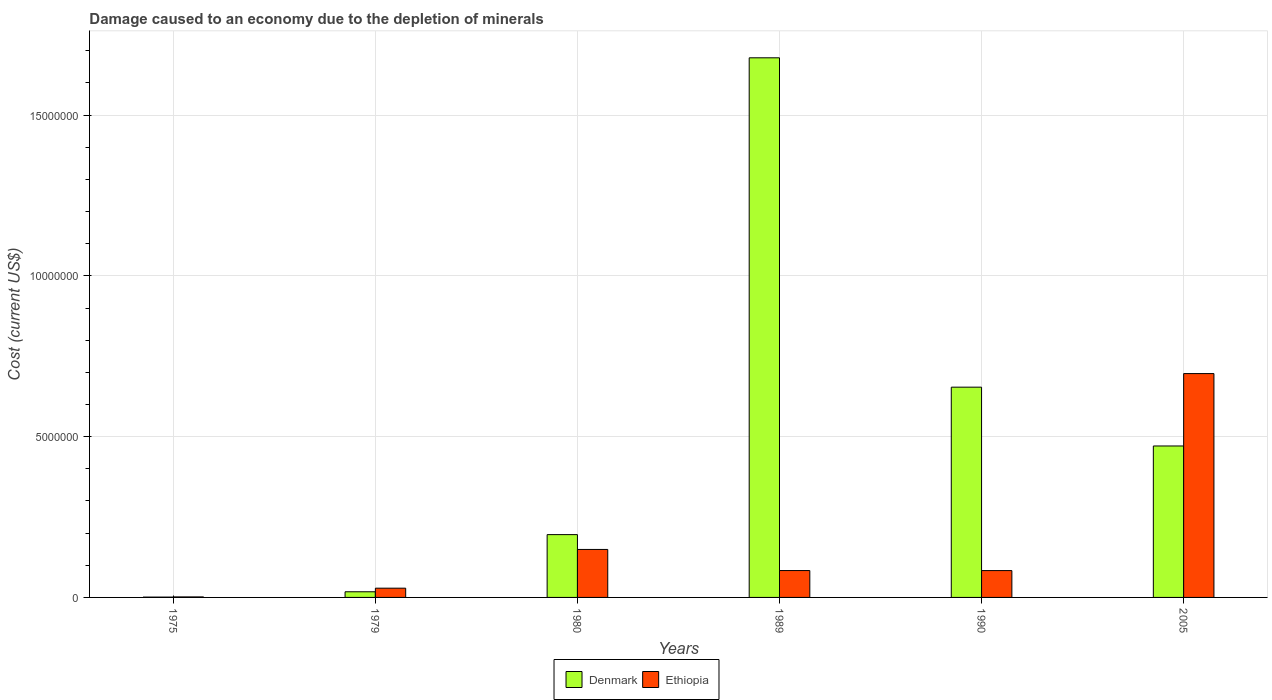How many different coloured bars are there?
Make the answer very short. 2. How many groups of bars are there?
Your answer should be very brief. 6. Are the number of bars on each tick of the X-axis equal?
Provide a short and direct response. Yes. What is the label of the 3rd group of bars from the left?
Your answer should be very brief. 1980. What is the cost of damage caused due to the depletion of minerals in Ethiopia in 1990?
Offer a terse response. 8.35e+05. Across all years, what is the maximum cost of damage caused due to the depletion of minerals in Denmark?
Offer a very short reply. 1.68e+07. Across all years, what is the minimum cost of damage caused due to the depletion of minerals in Ethiopia?
Offer a terse response. 1.59e+04. In which year was the cost of damage caused due to the depletion of minerals in Ethiopia minimum?
Provide a succinct answer. 1975. What is the total cost of damage caused due to the depletion of minerals in Ethiopia in the graph?
Offer a very short reply. 1.04e+07. What is the difference between the cost of damage caused due to the depletion of minerals in Ethiopia in 1975 and that in 2005?
Offer a terse response. -6.95e+06. What is the difference between the cost of damage caused due to the depletion of minerals in Ethiopia in 1979 and the cost of damage caused due to the depletion of minerals in Denmark in 1990?
Offer a terse response. -6.25e+06. What is the average cost of damage caused due to the depletion of minerals in Ethiopia per year?
Offer a terse response. 1.74e+06. In the year 1989, what is the difference between the cost of damage caused due to the depletion of minerals in Denmark and cost of damage caused due to the depletion of minerals in Ethiopia?
Provide a short and direct response. 1.59e+07. In how many years, is the cost of damage caused due to the depletion of minerals in Denmark greater than 4000000 US$?
Provide a succinct answer. 3. What is the ratio of the cost of damage caused due to the depletion of minerals in Denmark in 1975 to that in 2005?
Provide a succinct answer. 0. Is the cost of damage caused due to the depletion of minerals in Denmark in 1980 less than that in 2005?
Make the answer very short. Yes. What is the difference between the highest and the second highest cost of damage caused due to the depletion of minerals in Ethiopia?
Offer a very short reply. 5.47e+06. What is the difference between the highest and the lowest cost of damage caused due to the depletion of minerals in Ethiopia?
Provide a succinct answer. 6.95e+06. In how many years, is the cost of damage caused due to the depletion of minerals in Ethiopia greater than the average cost of damage caused due to the depletion of minerals in Ethiopia taken over all years?
Make the answer very short. 1. Is the sum of the cost of damage caused due to the depletion of minerals in Ethiopia in 1980 and 1990 greater than the maximum cost of damage caused due to the depletion of minerals in Denmark across all years?
Your response must be concise. No. What does the 1st bar from the right in 2005 represents?
Provide a short and direct response. Ethiopia. Are all the bars in the graph horizontal?
Ensure brevity in your answer.  No. What is the difference between two consecutive major ticks on the Y-axis?
Provide a succinct answer. 5.00e+06. Are the values on the major ticks of Y-axis written in scientific E-notation?
Ensure brevity in your answer.  No. Where does the legend appear in the graph?
Your answer should be compact. Bottom center. How are the legend labels stacked?
Your answer should be very brief. Horizontal. What is the title of the graph?
Provide a short and direct response. Damage caused to an economy due to the depletion of minerals. Does "Slovenia" appear as one of the legend labels in the graph?
Provide a succinct answer. No. What is the label or title of the Y-axis?
Your answer should be compact. Cost (current US$). What is the Cost (current US$) in Denmark in 1975?
Keep it short and to the point. 1.03e+04. What is the Cost (current US$) in Ethiopia in 1975?
Ensure brevity in your answer.  1.59e+04. What is the Cost (current US$) of Denmark in 1979?
Provide a short and direct response. 1.76e+05. What is the Cost (current US$) of Ethiopia in 1979?
Offer a very short reply. 2.88e+05. What is the Cost (current US$) of Denmark in 1980?
Provide a short and direct response. 1.95e+06. What is the Cost (current US$) in Ethiopia in 1980?
Give a very brief answer. 1.49e+06. What is the Cost (current US$) in Denmark in 1989?
Offer a very short reply. 1.68e+07. What is the Cost (current US$) of Ethiopia in 1989?
Provide a succinct answer. 8.36e+05. What is the Cost (current US$) in Denmark in 1990?
Your answer should be compact. 6.54e+06. What is the Cost (current US$) in Ethiopia in 1990?
Provide a succinct answer. 8.35e+05. What is the Cost (current US$) of Denmark in 2005?
Give a very brief answer. 4.71e+06. What is the Cost (current US$) in Ethiopia in 2005?
Your answer should be very brief. 6.96e+06. Across all years, what is the maximum Cost (current US$) of Denmark?
Offer a terse response. 1.68e+07. Across all years, what is the maximum Cost (current US$) of Ethiopia?
Provide a succinct answer. 6.96e+06. Across all years, what is the minimum Cost (current US$) of Denmark?
Give a very brief answer. 1.03e+04. Across all years, what is the minimum Cost (current US$) of Ethiopia?
Give a very brief answer. 1.59e+04. What is the total Cost (current US$) in Denmark in the graph?
Provide a short and direct response. 3.02e+07. What is the total Cost (current US$) in Ethiopia in the graph?
Your answer should be compact. 1.04e+07. What is the difference between the Cost (current US$) of Denmark in 1975 and that in 1979?
Provide a succinct answer. -1.66e+05. What is the difference between the Cost (current US$) of Ethiopia in 1975 and that in 1979?
Provide a short and direct response. -2.72e+05. What is the difference between the Cost (current US$) in Denmark in 1975 and that in 1980?
Your answer should be compact. -1.94e+06. What is the difference between the Cost (current US$) in Ethiopia in 1975 and that in 1980?
Keep it short and to the point. -1.48e+06. What is the difference between the Cost (current US$) in Denmark in 1975 and that in 1989?
Provide a short and direct response. -1.68e+07. What is the difference between the Cost (current US$) of Ethiopia in 1975 and that in 1989?
Give a very brief answer. -8.20e+05. What is the difference between the Cost (current US$) in Denmark in 1975 and that in 1990?
Your response must be concise. -6.53e+06. What is the difference between the Cost (current US$) in Ethiopia in 1975 and that in 1990?
Offer a terse response. -8.19e+05. What is the difference between the Cost (current US$) of Denmark in 1975 and that in 2005?
Provide a succinct answer. -4.70e+06. What is the difference between the Cost (current US$) in Ethiopia in 1975 and that in 2005?
Offer a very short reply. -6.95e+06. What is the difference between the Cost (current US$) of Denmark in 1979 and that in 1980?
Ensure brevity in your answer.  -1.78e+06. What is the difference between the Cost (current US$) in Ethiopia in 1979 and that in 1980?
Provide a short and direct response. -1.20e+06. What is the difference between the Cost (current US$) of Denmark in 1979 and that in 1989?
Offer a very short reply. -1.66e+07. What is the difference between the Cost (current US$) of Ethiopia in 1979 and that in 1989?
Provide a short and direct response. -5.48e+05. What is the difference between the Cost (current US$) of Denmark in 1979 and that in 1990?
Your answer should be compact. -6.36e+06. What is the difference between the Cost (current US$) in Ethiopia in 1979 and that in 1990?
Ensure brevity in your answer.  -5.47e+05. What is the difference between the Cost (current US$) of Denmark in 1979 and that in 2005?
Ensure brevity in your answer.  -4.53e+06. What is the difference between the Cost (current US$) in Ethiopia in 1979 and that in 2005?
Your response must be concise. -6.67e+06. What is the difference between the Cost (current US$) in Denmark in 1980 and that in 1989?
Provide a short and direct response. -1.48e+07. What is the difference between the Cost (current US$) in Ethiopia in 1980 and that in 1989?
Give a very brief answer. 6.57e+05. What is the difference between the Cost (current US$) in Denmark in 1980 and that in 1990?
Your answer should be compact. -4.59e+06. What is the difference between the Cost (current US$) in Ethiopia in 1980 and that in 1990?
Provide a succinct answer. 6.57e+05. What is the difference between the Cost (current US$) in Denmark in 1980 and that in 2005?
Provide a succinct answer. -2.76e+06. What is the difference between the Cost (current US$) in Ethiopia in 1980 and that in 2005?
Give a very brief answer. -5.47e+06. What is the difference between the Cost (current US$) of Denmark in 1989 and that in 1990?
Offer a terse response. 1.02e+07. What is the difference between the Cost (current US$) in Ethiopia in 1989 and that in 1990?
Your answer should be compact. 734.73. What is the difference between the Cost (current US$) in Denmark in 1989 and that in 2005?
Give a very brief answer. 1.21e+07. What is the difference between the Cost (current US$) of Ethiopia in 1989 and that in 2005?
Make the answer very short. -6.13e+06. What is the difference between the Cost (current US$) of Denmark in 1990 and that in 2005?
Offer a terse response. 1.83e+06. What is the difference between the Cost (current US$) in Ethiopia in 1990 and that in 2005?
Provide a succinct answer. -6.13e+06. What is the difference between the Cost (current US$) in Denmark in 1975 and the Cost (current US$) in Ethiopia in 1979?
Give a very brief answer. -2.77e+05. What is the difference between the Cost (current US$) of Denmark in 1975 and the Cost (current US$) of Ethiopia in 1980?
Provide a short and direct response. -1.48e+06. What is the difference between the Cost (current US$) in Denmark in 1975 and the Cost (current US$) in Ethiopia in 1989?
Offer a terse response. -8.25e+05. What is the difference between the Cost (current US$) of Denmark in 1975 and the Cost (current US$) of Ethiopia in 1990?
Ensure brevity in your answer.  -8.25e+05. What is the difference between the Cost (current US$) in Denmark in 1975 and the Cost (current US$) in Ethiopia in 2005?
Your answer should be very brief. -6.95e+06. What is the difference between the Cost (current US$) of Denmark in 1979 and the Cost (current US$) of Ethiopia in 1980?
Provide a succinct answer. -1.32e+06. What is the difference between the Cost (current US$) of Denmark in 1979 and the Cost (current US$) of Ethiopia in 1989?
Ensure brevity in your answer.  -6.60e+05. What is the difference between the Cost (current US$) in Denmark in 1979 and the Cost (current US$) in Ethiopia in 1990?
Keep it short and to the point. -6.59e+05. What is the difference between the Cost (current US$) in Denmark in 1979 and the Cost (current US$) in Ethiopia in 2005?
Offer a terse response. -6.79e+06. What is the difference between the Cost (current US$) in Denmark in 1980 and the Cost (current US$) in Ethiopia in 1989?
Offer a very short reply. 1.12e+06. What is the difference between the Cost (current US$) in Denmark in 1980 and the Cost (current US$) in Ethiopia in 1990?
Offer a terse response. 1.12e+06. What is the difference between the Cost (current US$) of Denmark in 1980 and the Cost (current US$) of Ethiopia in 2005?
Ensure brevity in your answer.  -5.01e+06. What is the difference between the Cost (current US$) in Denmark in 1989 and the Cost (current US$) in Ethiopia in 1990?
Provide a short and direct response. 1.59e+07. What is the difference between the Cost (current US$) of Denmark in 1989 and the Cost (current US$) of Ethiopia in 2005?
Offer a very short reply. 9.82e+06. What is the difference between the Cost (current US$) of Denmark in 1990 and the Cost (current US$) of Ethiopia in 2005?
Your response must be concise. -4.22e+05. What is the average Cost (current US$) in Denmark per year?
Provide a short and direct response. 5.03e+06. What is the average Cost (current US$) of Ethiopia per year?
Provide a short and direct response. 1.74e+06. In the year 1975, what is the difference between the Cost (current US$) in Denmark and Cost (current US$) in Ethiopia?
Make the answer very short. -5604.48. In the year 1979, what is the difference between the Cost (current US$) of Denmark and Cost (current US$) of Ethiopia?
Keep it short and to the point. -1.12e+05. In the year 1980, what is the difference between the Cost (current US$) in Denmark and Cost (current US$) in Ethiopia?
Ensure brevity in your answer.  4.61e+05. In the year 1989, what is the difference between the Cost (current US$) in Denmark and Cost (current US$) in Ethiopia?
Offer a very short reply. 1.59e+07. In the year 1990, what is the difference between the Cost (current US$) in Denmark and Cost (current US$) in Ethiopia?
Your answer should be compact. 5.70e+06. In the year 2005, what is the difference between the Cost (current US$) in Denmark and Cost (current US$) in Ethiopia?
Provide a short and direct response. -2.25e+06. What is the ratio of the Cost (current US$) of Denmark in 1975 to that in 1979?
Your response must be concise. 0.06. What is the ratio of the Cost (current US$) of Ethiopia in 1975 to that in 1979?
Your answer should be very brief. 0.06. What is the ratio of the Cost (current US$) in Denmark in 1975 to that in 1980?
Provide a succinct answer. 0.01. What is the ratio of the Cost (current US$) of Ethiopia in 1975 to that in 1980?
Ensure brevity in your answer.  0.01. What is the ratio of the Cost (current US$) in Denmark in 1975 to that in 1989?
Provide a succinct answer. 0. What is the ratio of the Cost (current US$) of Ethiopia in 1975 to that in 1989?
Make the answer very short. 0.02. What is the ratio of the Cost (current US$) in Denmark in 1975 to that in 1990?
Provide a succinct answer. 0. What is the ratio of the Cost (current US$) of Ethiopia in 1975 to that in 1990?
Make the answer very short. 0.02. What is the ratio of the Cost (current US$) of Denmark in 1975 to that in 2005?
Ensure brevity in your answer.  0. What is the ratio of the Cost (current US$) of Ethiopia in 1975 to that in 2005?
Make the answer very short. 0. What is the ratio of the Cost (current US$) in Denmark in 1979 to that in 1980?
Your response must be concise. 0.09. What is the ratio of the Cost (current US$) of Ethiopia in 1979 to that in 1980?
Keep it short and to the point. 0.19. What is the ratio of the Cost (current US$) in Denmark in 1979 to that in 1989?
Keep it short and to the point. 0.01. What is the ratio of the Cost (current US$) of Ethiopia in 1979 to that in 1989?
Offer a very short reply. 0.34. What is the ratio of the Cost (current US$) of Denmark in 1979 to that in 1990?
Offer a terse response. 0.03. What is the ratio of the Cost (current US$) of Ethiopia in 1979 to that in 1990?
Offer a terse response. 0.34. What is the ratio of the Cost (current US$) of Denmark in 1979 to that in 2005?
Your response must be concise. 0.04. What is the ratio of the Cost (current US$) in Ethiopia in 1979 to that in 2005?
Provide a succinct answer. 0.04. What is the ratio of the Cost (current US$) in Denmark in 1980 to that in 1989?
Give a very brief answer. 0.12. What is the ratio of the Cost (current US$) of Ethiopia in 1980 to that in 1989?
Your answer should be compact. 1.79. What is the ratio of the Cost (current US$) in Denmark in 1980 to that in 1990?
Offer a very short reply. 0.3. What is the ratio of the Cost (current US$) of Ethiopia in 1980 to that in 1990?
Your answer should be compact. 1.79. What is the ratio of the Cost (current US$) in Denmark in 1980 to that in 2005?
Your answer should be very brief. 0.41. What is the ratio of the Cost (current US$) in Ethiopia in 1980 to that in 2005?
Keep it short and to the point. 0.21. What is the ratio of the Cost (current US$) in Denmark in 1989 to that in 1990?
Give a very brief answer. 2.57. What is the ratio of the Cost (current US$) in Denmark in 1989 to that in 2005?
Offer a terse response. 3.56. What is the ratio of the Cost (current US$) in Ethiopia in 1989 to that in 2005?
Provide a short and direct response. 0.12. What is the ratio of the Cost (current US$) of Denmark in 1990 to that in 2005?
Offer a very short reply. 1.39. What is the ratio of the Cost (current US$) of Ethiopia in 1990 to that in 2005?
Your response must be concise. 0.12. What is the difference between the highest and the second highest Cost (current US$) in Denmark?
Your answer should be very brief. 1.02e+07. What is the difference between the highest and the second highest Cost (current US$) in Ethiopia?
Your response must be concise. 5.47e+06. What is the difference between the highest and the lowest Cost (current US$) of Denmark?
Your answer should be very brief. 1.68e+07. What is the difference between the highest and the lowest Cost (current US$) of Ethiopia?
Offer a terse response. 6.95e+06. 